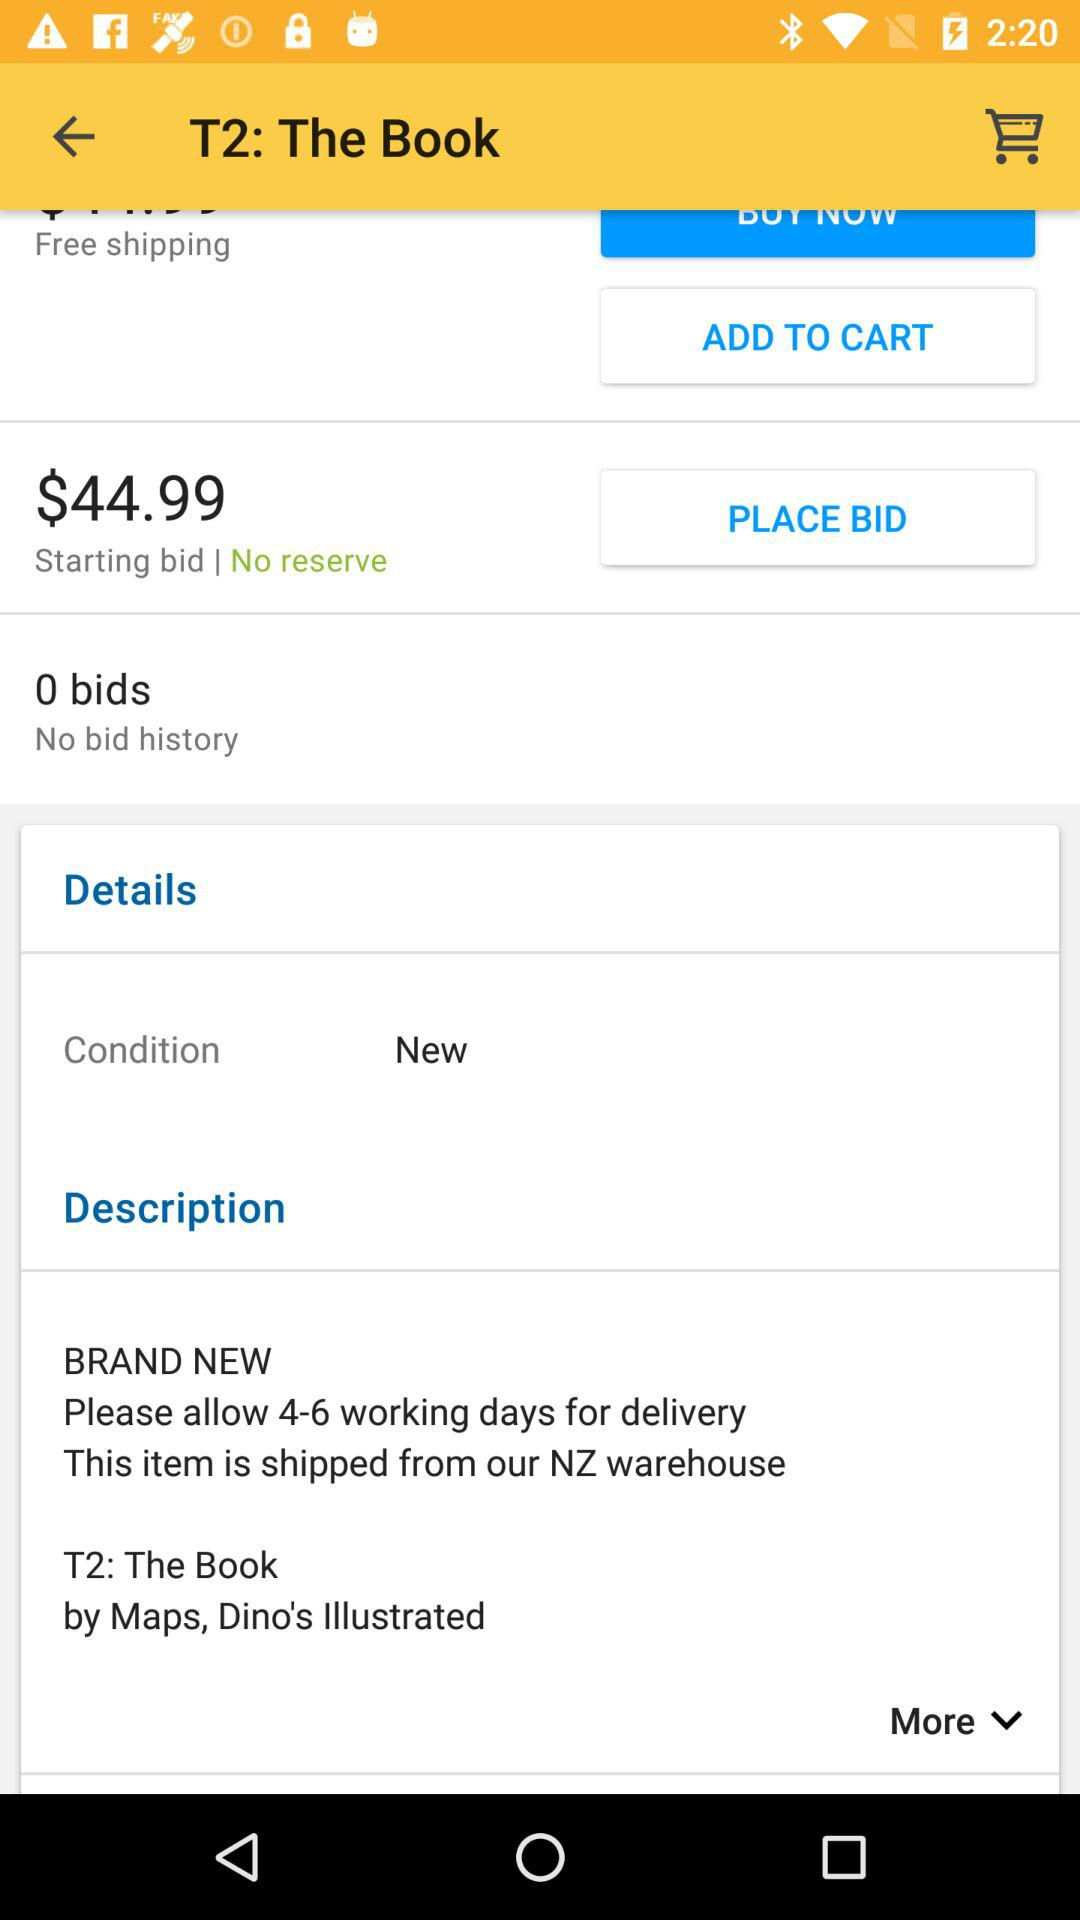How many bids are there on this item?
Answer the question using a single word or phrase. 0 